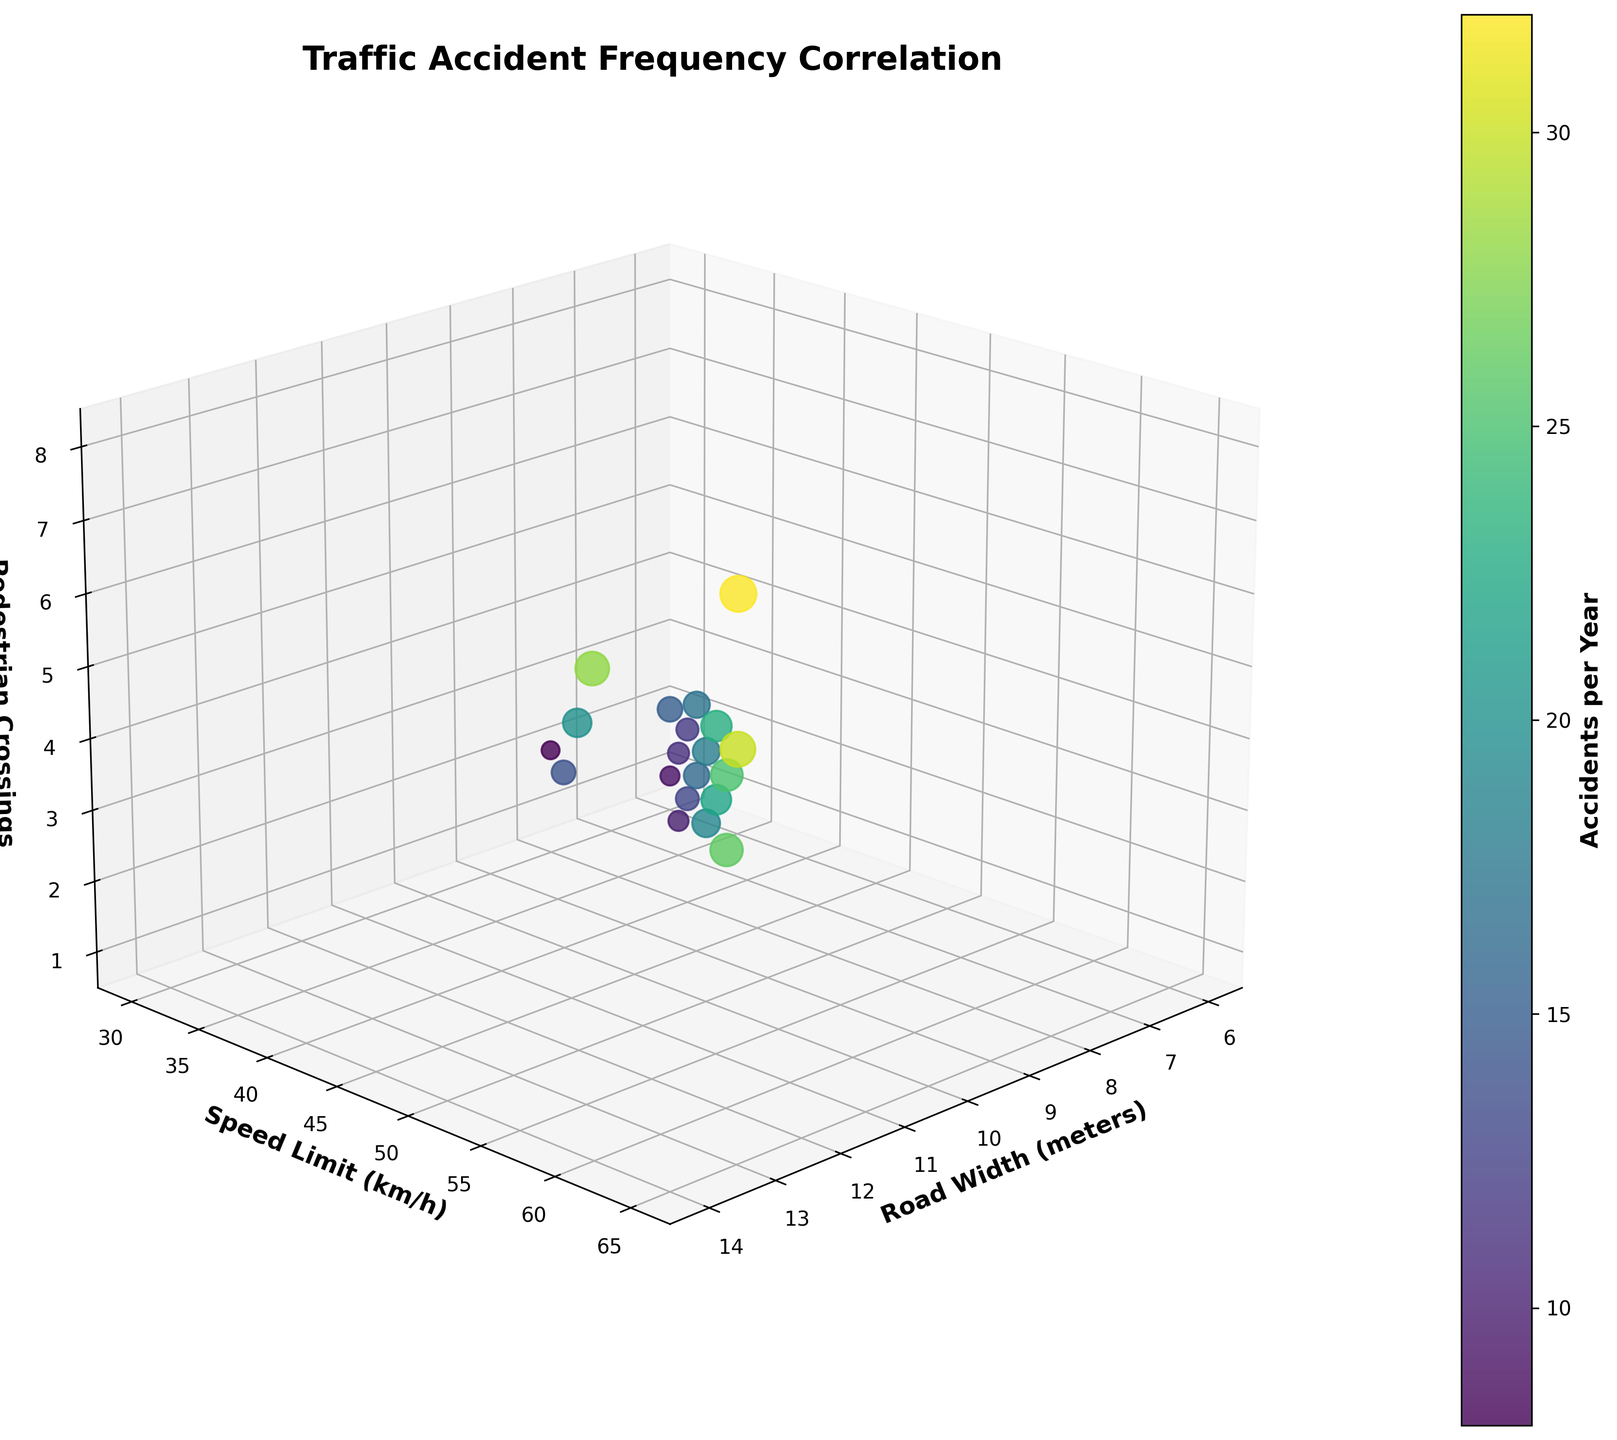What is the title of the figure? The title is located at the top of the figure and often summarizes what the figure is about. In this case, it describes the correlation being examined.
Answer: Traffic Accident Frequency Correlation How is accident frequency visually represented in the figure? Accident frequency is represented using color intensity and bubble size. Darker colors and larger bubbles indicate higher accident frequencies.
Answer: Color intensity and bubble size Which axis represents Speed Limit and what unit is used? The axis labels are crucial for understanding what each axis represents and its respective unit. The y-axis label mentions "Speed Limit" and the unit "km/h".
Answer: Y-axis, km/h How many pedestrian crossings are shown for the highest accident frequency? By looking at the data point with the darkest color and largest size, you can trace it to the z-axis to see the corresponding number of pedestrian crossings.
Answer: 8 What trend can be observed with increasing road width concerning accident frequency? Observing the data points along the x-axis (road width) while noting the color and size changes can help discern any trends in accident frequency.
Answer: Accident frequency seems to generally increase with road width Which data point has the lowest accident frequency and what are its corresponding road width, speed limit, and pedestrian crossings? By finding the smallest and lightest-colored bubble, you can trace back to the values on each axis to identify the specific data point.
Answer: 8m road width, 30 km/h speed limit, 2 pedestrian crossings Is there any correlation between the number of pedestrian crossings and accident frequency? To answer this, observe the distribution of colors and bubble sizes along the z-axis to see if there’s a pattern in accident frequencies with changes in pedestrian crossings.
Answer: Generally, more pedestrian crossings correlate with higher accident frequencies How does the speed limit affect accident frequency across different road widths? Compare bubbles of the same color (accident frequency) across different road widths and note the speed limits on the y-axis to identify any patterns.
Answer: Higher speed limits tend to correlate with higher accident frequencies What is the accident frequency for a road with 10m width, a speed limit of 50 km/h, and 4 pedestrian crossings? By locating the corresponding point in the 3D space and checking its color and size, you can find the accident frequency value.
Answer: 18 Which combination of road width and speed limit appears to have the most significant impact on accident frequency? Find the points with the darkest and largest bubbles, and note their x (road width) and y (speed limit) positions to identify the most impactful combinations.
Answer: 13m road width and 65 km/h speed limit 